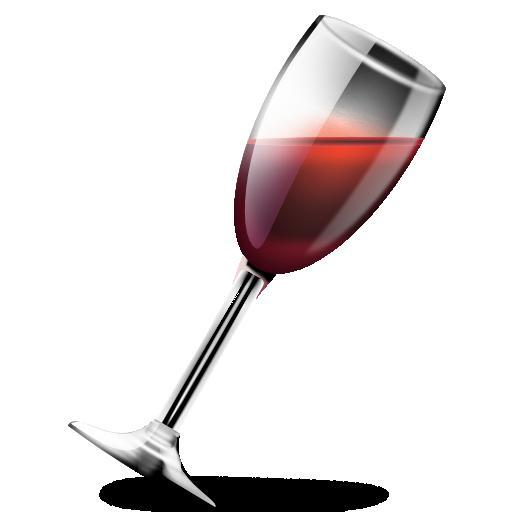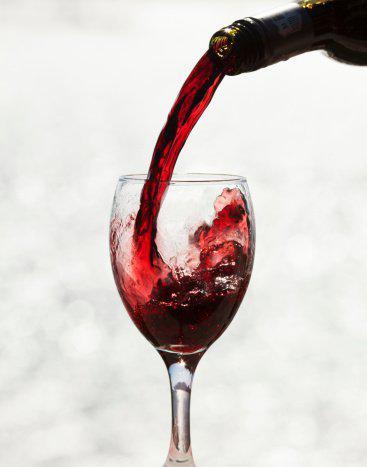The first image is the image on the left, the second image is the image on the right. Examine the images to the left and right. Is the description "Wine is pouring into the glass in the image on the right." accurate? Answer yes or no. Yes. The first image is the image on the left, the second image is the image on the right. Examine the images to the left and right. Is the description "Red wine is pouring into a glass, creating a splash inside the glass." accurate? Answer yes or no. Yes. 